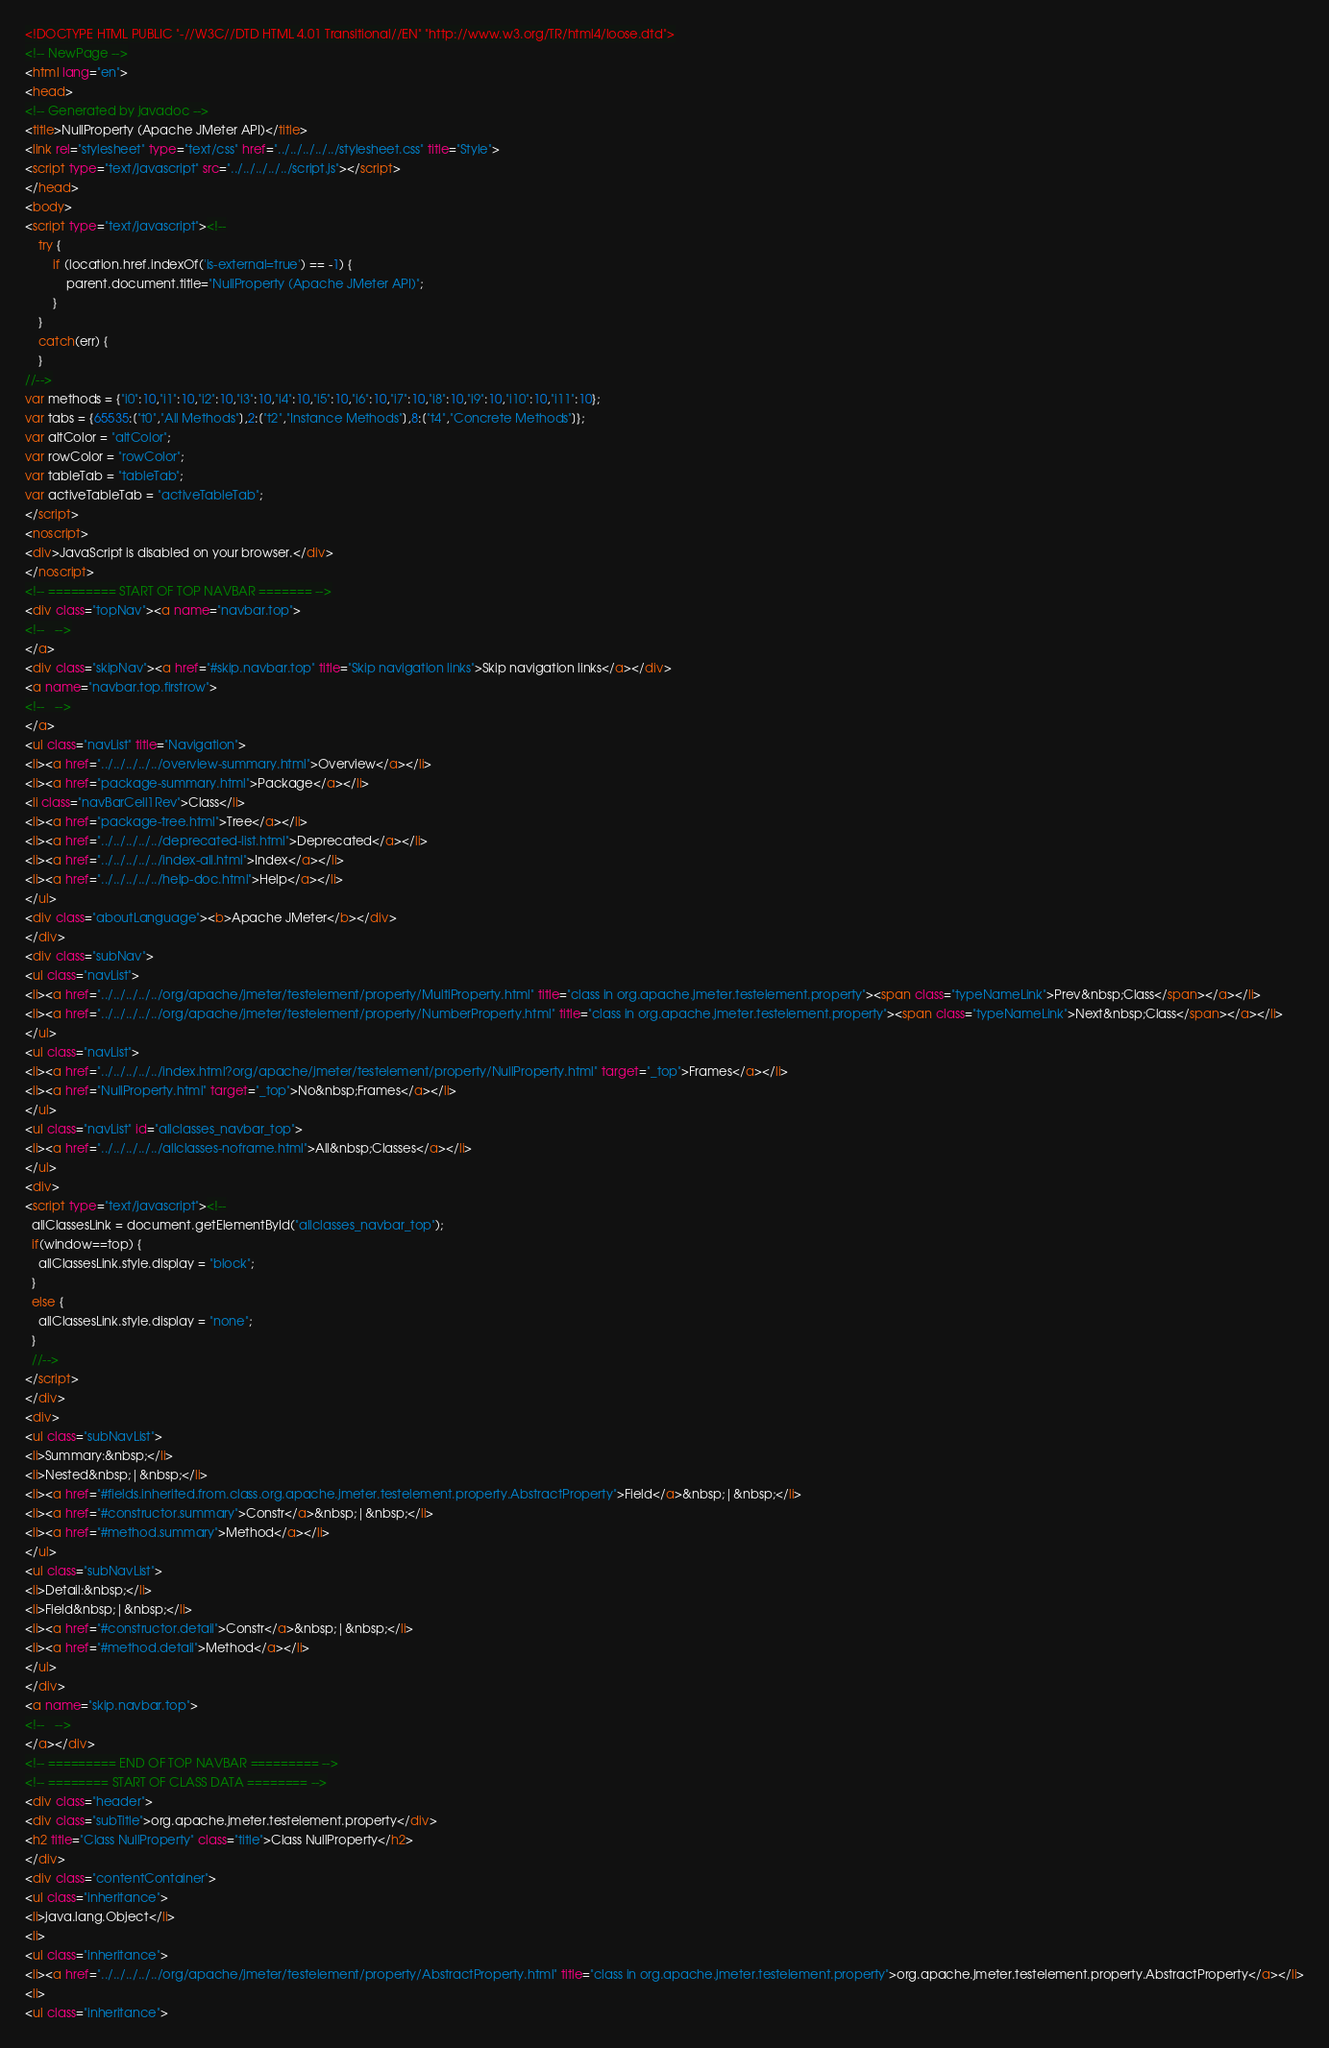Convert code to text. <code><loc_0><loc_0><loc_500><loc_500><_HTML_><!DOCTYPE HTML PUBLIC "-//W3C//DTD HTML 4.01 Transitional//EN" "http://www.w3.org/TR/html4/loose.dtd">
<!-- NewPage -->
<html lang="en">
<head>
<!-- Generated by javadoc -->
<title>NullProperty (Apache JMeter API)</title>
<link rel="stylesheet" type="text/css" href="../../../../../stylesheet.css" title="Style">
<script type="text/javascript" src="../../../../../script.js"></script>
</head>
<body>
<script type="text/javascript"><!--
    try {
        if (location.href.indexOf('is-external=true') == -1) {
            parent.document.title="NullProperty (Apache JMeter API)";
        }
    }
    catch(err) {
    }
//-->
var methods = {"i0":10,"i1":10,"i2":10,"i3":10,"i4":10,"i5":10,"i6":10,"i7":10,"i8":10,"i9":10,"i10":10,"i11":10};
var tabs = {65535:["t0","All Methods"],2:["t2","Instance Methods"],8:["t4","Concrete Methods"]};
var altColor = "altColor";
var rowColor = "rowColor";
var tableTab = "tableTab";
var activeTableTab = "activeTableTab";
</script>
<noscript>
<div>JavaScript is disabled on your browser.</div>
</noscript>
<!-- ========= START OF TOP NAVBAR ======= -->
<div class="topNav"><a name="navbar.top">
<!--   -->
</a>
<div class="skipNav"><a href="#skip.navbar.top" title="Skip navigation links">Skip navigation links</a></div>
<a name="navbar.top.firstrow">
<!--   -->
</a>
<ul class="navList" title="Navigation">
<li><a href="../../../../../overview-summary.html">Overview</a></li>
<li><a href="package-summary.html">Package</a></li>
<li class="navBarCell1Rev">Class</li>
<li><a href="package-tree.html">Tree</a></li>
<li><a href="../../../../../deprecated-list.html">Deprecated</a></li>
<li><a href="../../../../../index-all.html">Index</a></li>
<li><a href="../../../../../help-doc.html">Help</a></li>
</ul>
<div class="aboutLanguage"><b>Apache JMeter</b></div>
</div>
<div class="subNav">
<ul class="navList">
<li><a href="../../../../../org/apache/jmeter/testelement/property/MultiProperty.html" title="class in org.apache.jmeter.testelement.property"><span class="typeNameLink">Prev&nbsp;Class</span></a></li>
<li><a href="../../../../../org/apache/jmeter/testelement/property/NumberProperty.html" title="class in org.apache.jmeter.testelement.property"><span class="typeNameLink">Next&nbsp;Class</span></a></li>
</ul>
<ul class="navList">
<li><a href="../../../../../index.html?org/apache/jmeter/testelement/property/NullProperty.html" target="_top">Frames</a></li>
<li><a href="NullProperty.html" target="_top">No&nbsp;Frames</a></li>
</ul>
<ul class="navList" id="allclasses_navbar_top">
<li><a href="../../../../../allclasses-noframe.html">All&nbsp;Classes</a></li>
</ul>
<div>
<script type="text/javascript"><!--
  allClassesLink = document.getElementById("allclasses_navbar_top");
  if(window==top) {
    allClassesLink.style.display = "block";
  }
  else {
    allClassesLink.style.display = "none";
  }
  //-->
</script>
</div>
<div>
<ul class="subNavList">
<li>Summary:&nbsp;</li>
<li>Nested&nbsp;|&nbsp;</li>
<li><a href="#fields.inherited.from.class.org.apache.jmeter.testelement.property.AbstractProperty">Field</a>&nbsp;|&nbsp;</li>
<li><a href="#constructor.summary">Constr</a>&nbsp;|&nbsp;</li>
<li><a href="#method.summary">Method</a></li>
</ul>
<ul class="subNavList">
<li>Detail:&nbsp;</li>
<li>Field&nbsp;|&nbsp;</li>
<li><a href="#constructor.detail">Constr</a>&nbsp;|&nbsp;</li>
<li><a href="#method.detail">Method</a></li>
</ul>
</div>
<a name="skip.navbar.top">
<!--   -->
</a></div>
<!-- ========= END OF TOP NAVBAR ========= -->
<!-- ======== START OF CLASS DATA ======== -->
<div class="header">
<div class="subTitle">org.apache.jmeter.testelement.property</div>
<h2 title="Class NullProperty" class="title">Class NullProperty</h2>
</div>
<div class="contentContainer">
<ul class="inheritance">
<li>java.lang.Object</li>
<li>
<ul class="inheritance">
<li><a href="../../../../../org/apache/jmeter/testelement/property/AbstractProperty.html" title="class in org.apache.jmeter.testelement.property">org.apache.jmeter.testelement.property.AbstractProperty</a></li>
<li>
<ul class="inheritance"></code> 